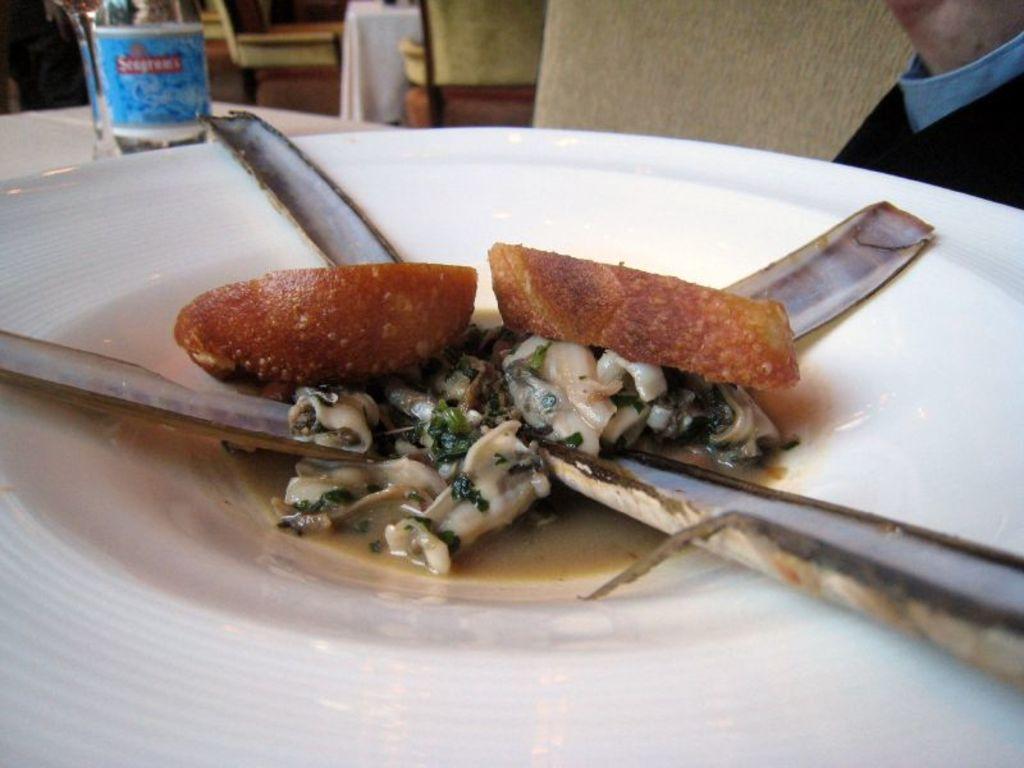Describe this image in one or two sentences. Here we can see plate with food and bottle on the table. Background we can see chairs. 